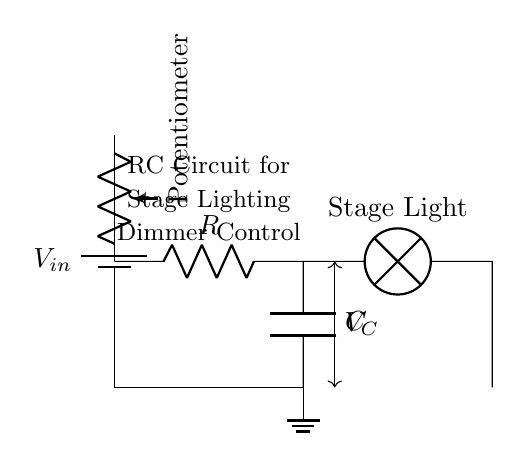What is the source voltage in this circuit? The source voltage is labeled as \( V_{in} \) in the circuit diagram, indicative of the power supply connected at the top.
Answer: \( V_{in} \) Which component is responsible for adjusting the brightness of the stage light? The potentiometer is used for adjusting the resistance, which controls the current flow and therefore the brightness of the stage light.
Answer: Potentiometer What is the role of the capacitor in this circuit? The capacitor smooths out voltage fluctuations by charging and discharging, providing a stable power supply to the stage light.
Answer: Voltage stabilization How does increasing the resistance affect the brightness of the stage light? Increasing the resistance from the potentiometer results in less current flowing to the stage light, thus dimming it.
Answer: Dims the light What is the load represented in this circuit? The load in this circuit is represented as the stage light which utilizes the voltage provided by the circuit to produce illumination.
Answer: Stage Light How does the capacitor affect the time response of the circuit? The capacitor introduces a time delay in the circuit response, dictating how quickly the stage light can turn on or off based on the charging and discharging cycles.
Answer: Time delay What is the connection type between the capacitor and the stage light? The connection type is series, as the positive terminal of the capacitor is connected directly to the stage light, indicating that they are in line with each other along the circuit.
Answer: Series connection 